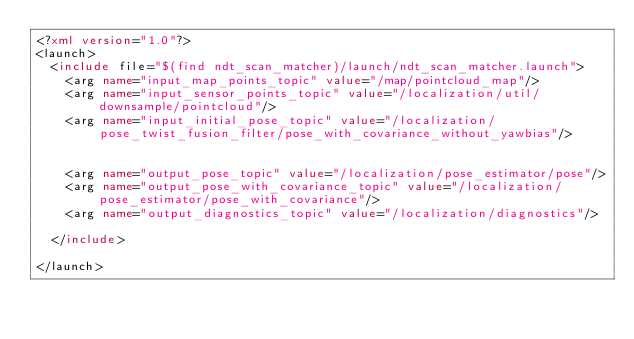<code> <loc_0><loc_0><loc_500><loc_500><_XML_><?xml version="1.0"?>
<launch>
  <include file="$(find ndt_scan_matcher)/launch/ndt_scan_matcher.launch">
    <arg name="input_map_points_topic" value="/map/pointcloud_map"/>
    <arg name="input_sensor_points_topic" value="/localization/util/downsample/pointcloud"/>
    <arg name="input_initial_pose_topic" value="/localization/pose_twist_fusion_filter/pose_with_covariance_without_yawbias"/>


    <arg name="output_pose_topic" value="/localization/pose_estimator/pose"/>
    <arg name="output_pose_with_covariance_topic" value="/localization/pose_estimator/pose_with_covariance"/>
    <arg name="output_diagnostics_topic" value="/localization/diagnostics"/>

  </include>

</launch>
</code> 